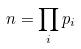<formula> <loc_0><loc_0><loc_500><loc_500>n = \prod _ { i } p _ { i }</formula> 